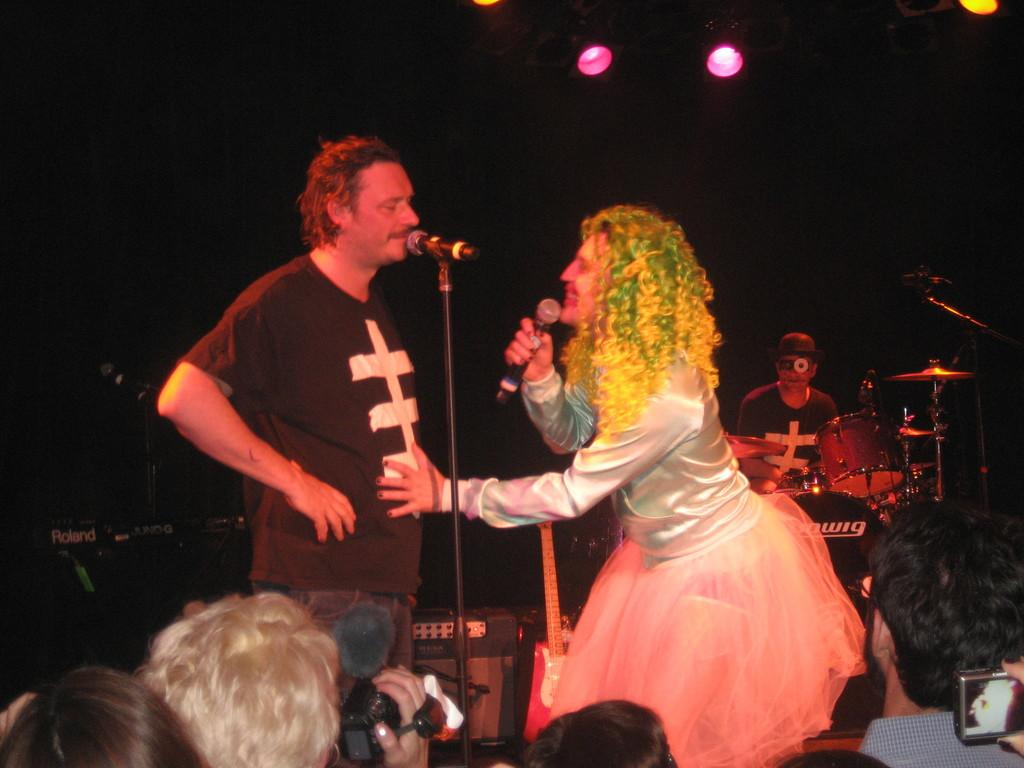How many people are present in the image? There are two people in the image, a lady and a man. What type of milk is the man drinking in the image? There is no milk present in the image, and the man is not shown drinking anything. 